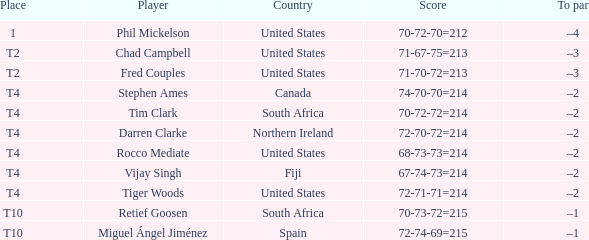Where is Fred Couples from? United States. 